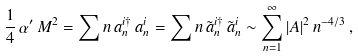Convert formula to latex. <formula><loc_0><loc_0><loc_500><loc_500>\frac { 1 } { 4 } \, \alpha ^ { \prime } \, M ^ { 2 } = \sum n \, a _ { n } ^ { i \dagger } \, a _ { n } ^ { i } = \sum n \, \tilde { a } _ { n } ^ { i \dagger } \, \tilde { a } _ { n } ^ { i } \sim \sum _ { n = 1 } ^ { \infty } | A | ^ { 2 } \, n ^ { - 4 / 3 } \, ,</formula> 